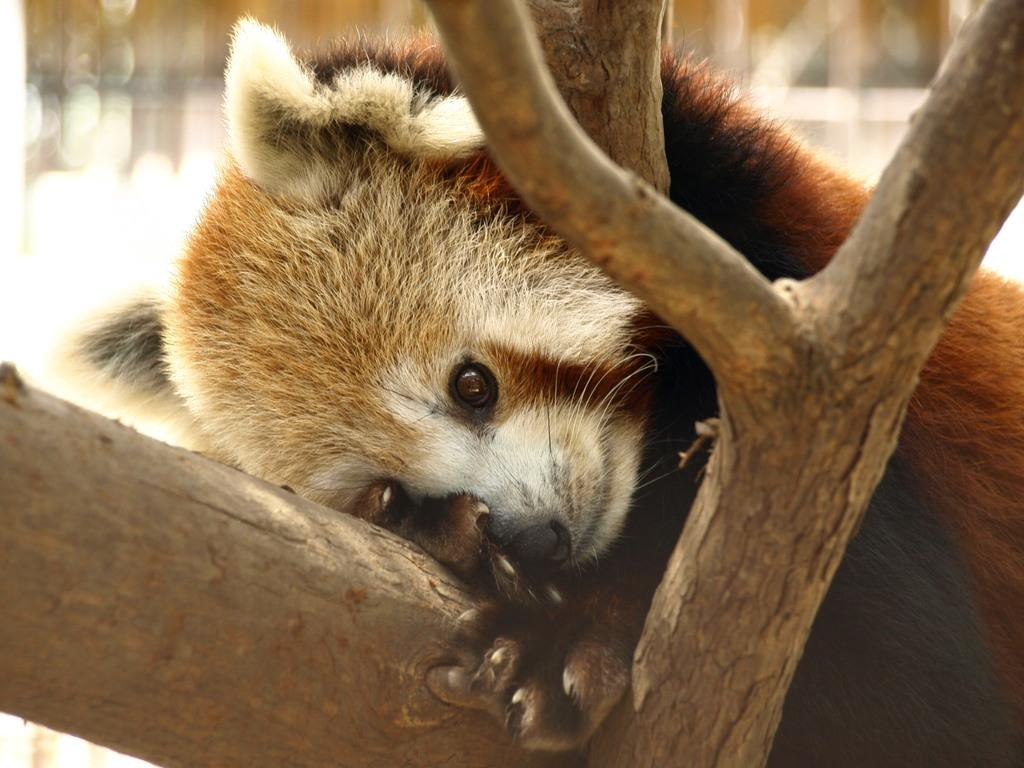What type of animal is in the image? There is an animal in the image, but the specific type cannot be determined from the provided facts. Where is the animal located in the image? The animal is on a tree in the image. What can be said about the background of the image? The background of the image is blurred. What is the animal's annual income in the image? There is no information about the animal's income in the image. How is the animal measuring the distance between branches in the image? There is no information about the animal measuring distances in the image. 